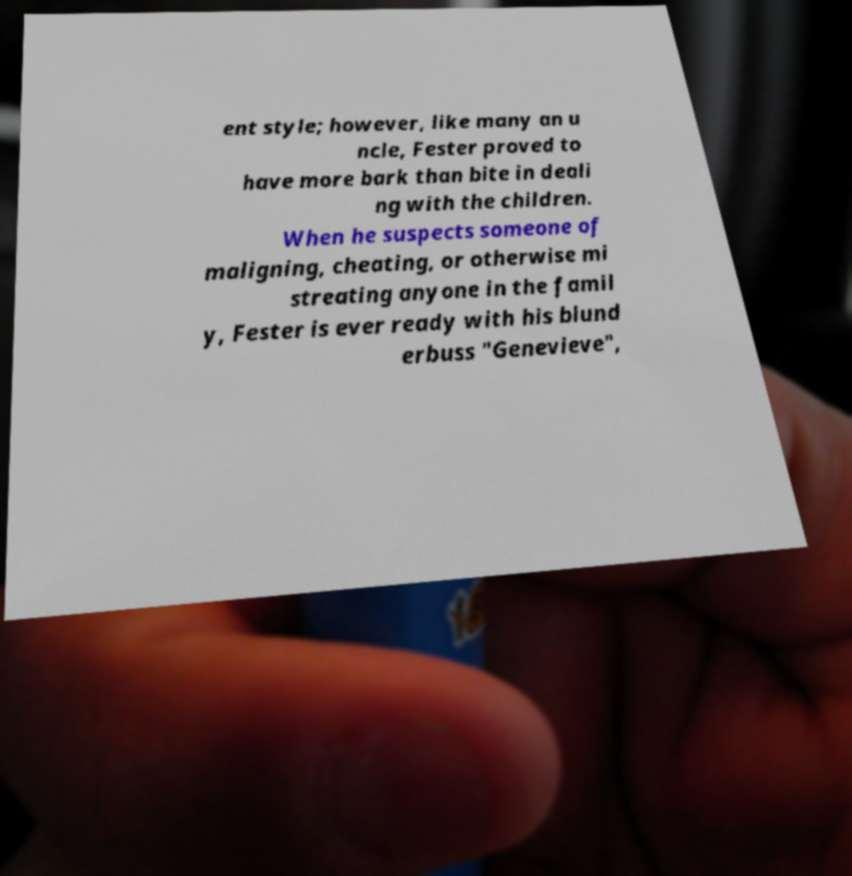There's text embedded in this image that I need extracted. Can you transcribe it verbatim? ent style; however, like many an u ncle, Fester proved to have more bark than bite in deali ng with the children. When he suspects someone of maligning, cheating, or otherwise mi streating anyone in the famil y, Fester is ever ready with his blund erbuss "Genevieve", 